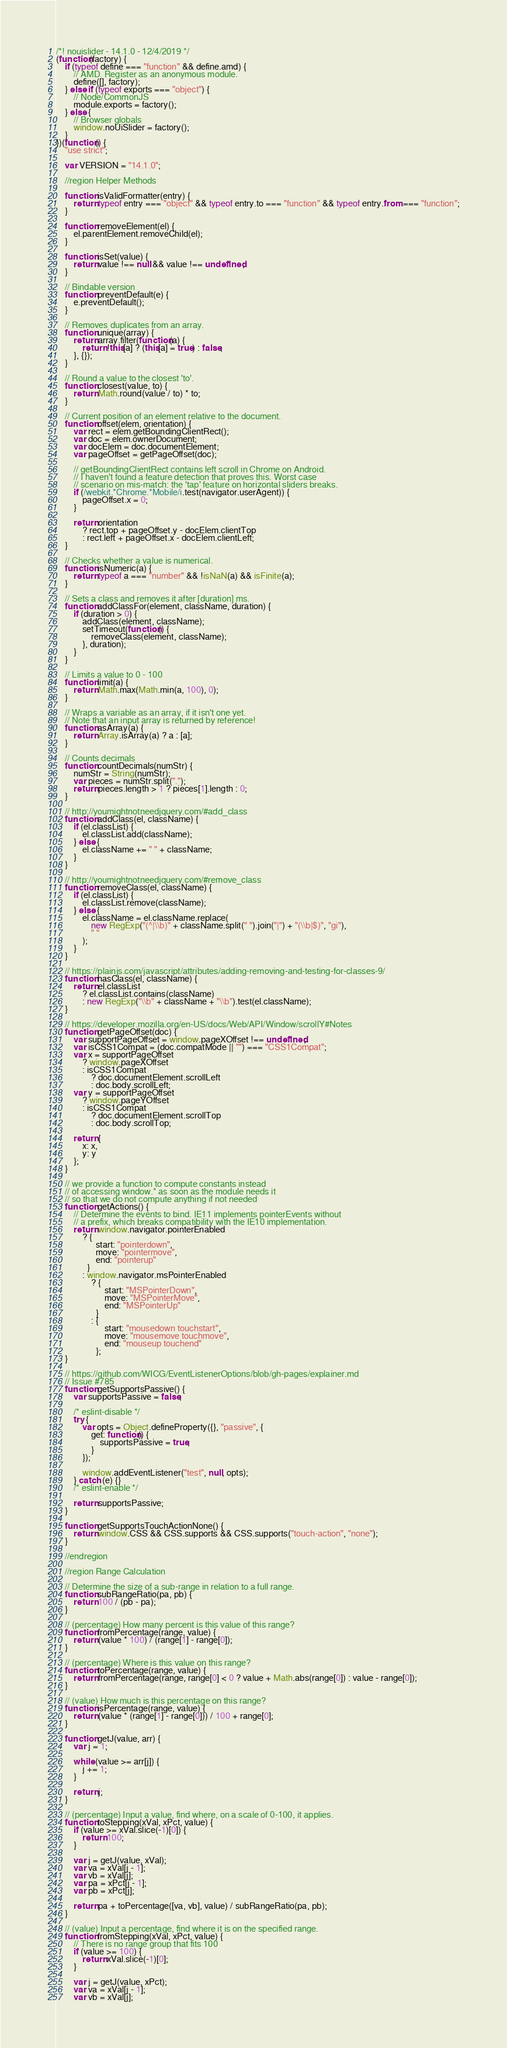<code> <loc_0><loc_0><loc_500><loc_500><_JavaScript_>/*! nouislider - 14.1.0 - 12/4/2019 */
(function(factory) {
    if (typeof define === "function" && define.amd) {
        // AMD. Register as an anonymous module.
        define([], factory);
    } else if (typeof exports === "object") {
        // Node/CommonJS
        module.exports = factory();
    } else {
        // Browser globals
        window.noUiSlider = factory();
    }
})(function() {
    "use strict";

    var VERSION = "14.1.0";

    //region Helper Methods

    function isValidFormatter(entry) {
        return typeof entry === "object" && typeof entry.to === "function" && typeof entry.from === "function";
    }

    function removeElement(el) {
        el.parentElement.removeChild(el);
    }

    function isSet(value) {
        return value !== null && value !== undefined;
    }

    // Bindable version
    function preventDefault(e) {
        e.preventDefault();
    }

    // Removes duplicates from an array.
    function unique(array) {
        return array.filter(function(a) {
            return !this[a] ? (this[a] = true) : false;
        }, {});
    }

    // Round a value to the closest 'to'.
    function closest(value, to) {
        return Math.round(value / to) * to;
    }

    // Current position of an element relative to the document.
    function offset(elem, orientation) {
        var rect = elem.getBoundingClientRect();
        var doc = elem.ownerDocument;
        var docElem = doc.documentElement;
        var pageOffset = getPageOffset(doc);

        // getBoundingClientRect contains left scroll in Chrome on Android.
        // I haven't found a feature detection that proves this. Worst case
        // scenario on mis-match: the 'tap' feature on horizontal sliders breaks.
        if (/webkit.*Chrome.*Mobile/i.test(navigator.userAgent)) {
            pageOffset.x = 0;
        }

        return orientation
            ? rect.top + pageOffset.y - docElem.clientTop
            : rect.left + pageOffset.x - docElem.clientLeft;
    }

    // Checks whether a value is numerical.
    function isNumeric(a) {
        return typeof a === "number" && !isNaN(a) && isFinite(a);
    }

    // Sets a class and removes it after [duration] ms.
    function addClassFor(element, className, duration) {
        if (duration > 0) {
            addClass(element, className);
            setTimeout(function() {
                removeClass(element, className);
            }, duration);
        }
    }

    // Limits a value to 0 - 100
    function limit(a) {
        return Math.max(Math.min(a, 100), 0);
    }

    // Wraps a variable as an array, if it isn't one yet.
    // Note that an input array is returned by reference!
    function asArray(a) {
        return Array.isArray(a) ? a : [a];
    }

    // Counts decimals
    function countDecimals(numStr) {
        numStr = String(numStr);
        var pieces = numStr.split(".");
        return pieces.length > 1 ? pieces[1].length : 0;
    }

    // http://youmightnotneedjquery.com/#add_class
    function addClass(el, className) {
        if (el.classList) {
            el.classList.add(className);
        } else {
            el.className += " " + className;
        }
    }

    // http://youmightnotneedjquery.com/#remove_class
    function removeClass(el, className) {
        if (el.classList) {
            el.classList.remove(className);
        } else {
            el.className = el.className.replace(
                new RegExp("(^|\\b)" + className.split(" ").join("|") + "(\\b|$)", "gi"),
                " "
            );
        }
    }

    // https://plainjs.com/javascript/attributes/adding-removing-and-testing-for-classes-9/
    function hasClass(el, className) {
        return el.classList
            ? el.classList.contains(className)
            : new RegExp("\\b" + className + "\\b").test(el.className);
    }

    // https://developer.mozilla.org/en-US/docs/Web/API/Window/scrollY#Notes
    function getPageOffset(doc) {
        var supportPageOffset = window.pageXOffset !== undefined;
        var isCSS1Compat = (doc.compatMode || "") === "CSS1Compat";
        var x = supportPageOffset
            ? window.pageXOffset
            : isCSS1Compat
                ? doc.documentElement.scrollLeft
                : doc.body.scrollLeft;
        var y = supportPageOffset
            ? window.pageYOffset
            : isCSS1Compat
                ? doc.documentElement.scrollTop
                : doc.body.scrollTop;

        return {
            x: x,
            y: y
        };
    }

    // we provide a function to compute constants instead
    // of accessing window.* as soon as the module needs it
    // so that we do not compute anything if not needed
    function getActions() {
        // Determine the events to bind. IE11 implements pointerEvents without
        // a prefix, which breaks compatibility with the IE10 implementation.
        return window.navigator.pointerEnabled
            ? {
                  start: "pointerdown",
                  move: "pointermove",
                  end: "pointerup"
              }
            : window.navigator.msPointerEnabled
                ? {
                      start: "MSPointerDown",
                      move: "MSPointerMove",
                      end: "MSPointerUp"
                  }
                : {
                      start: "mousedown touchstart",
                      move: "mousemove touchmove",
                      end: "mouseup touchend"
                  };
    }

    // https://github.com/WICG/EventListenerOptions/blob/gh-pages/explainer.md
    // Issue #785
    function getSupportsPassive() {
        var supportsPassive = false;

        /* eslint-disable */
        try {
            var opts = Object.defineProperty({}, "passive", {
                get: function() {
                    supportsPassive = true;
                }
            });

            window.addEventListener("test", null, opts);
        } catch (e) {}
        /* eslint-enable */

        return supportsPassive;
    }

    function getSupportsTouchActionNone() {
        return window.CSS && CSS.supports && CSS.supports("touch-action", "none");
    }

    //endregion

    //region Range Calculation

    // Determine the size of a sub-range in relation to a full range.
    function subRangeRatio(pa, pb) {
        return 100 / (pb - pa);
    }

    // (percentage) How many percent is this value of this range?
    function fromPercentage(range, value) {
        return (value * 100) / (range[1] - range[0]);
    }

    // (percentage) Where is this value on this range?
    function toPercentage(range, value) {
        return fromPercentage(range, range[0] < 0 ? value + Math.abs(range[0]) : value - range[0]);
    }

    // (value) How much is this percentage on this range?
    function isPercentage(range, value) {
        return (value * (range[1] - range[0])) / 100 + range[0];
    }

    function getJ(value, arr) {
        var j = 1;

        while (value >= arr[j]) {
            j += 1;
        }

        return j;
    }

    // (percentage) Input a value, find where, on a scale of 0-100, it applies.
    function toStepping(xVal, xPct, value) {
        if (value >= xVal.slice(-1)[0]) {
            return 100;
        }

        var j = getJ(value, xVal);
        var va = xVal[j - 1];
        var vb = xVal[j];
        var pa = xPct[j - 1];
        var pb = xPct[j];

        return pa + toPercentage([va, vb], value) / subRangeRatio(pa, pb);
    }

    // (value) Input a percentage, find where it is on the specified range.
    function fromStepping(xVal, xPct, value) {
        // There is no range group that fits 100
        if (value >= 100) {
            return xVal.slice(-1)[0];
        }

        var j = getJ(value, xPct);
        var va = xVal[j - 1];
        var vb = xVal[j];</code> 